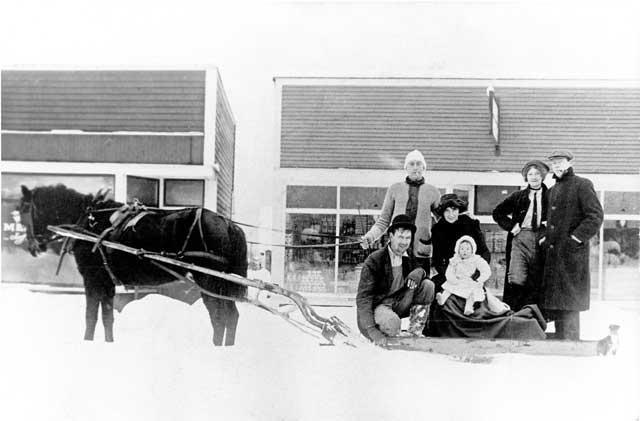How many people are posed?
Give a very brief answer. 6. How many people are there?
Give a very brief answer. 6. 